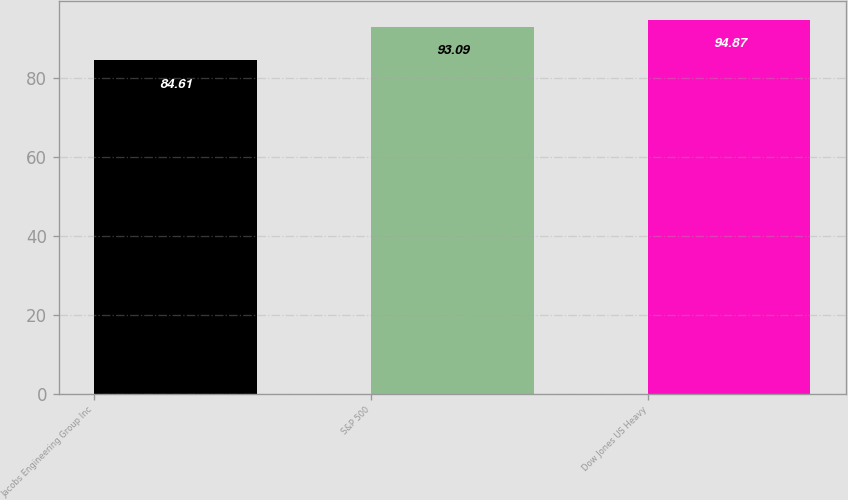Convert chart to OTSL. <chart><loc_0><loc_0><loc_500><loc_500><bar_chart><fcel>Jacobs Engineering Group Inc<fcel>S&P 500<fcel>Dow Jones US Heavy<nl><fcel>84.61<fcel>93.09<fcel>94.87<nl></chart> 